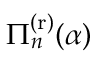Convert formula to latex. <formula><loc_0><loc_0><loc_500><loc_500>\Pi _ { n } ^ { ( r ) } ( \alpha )</formula> 